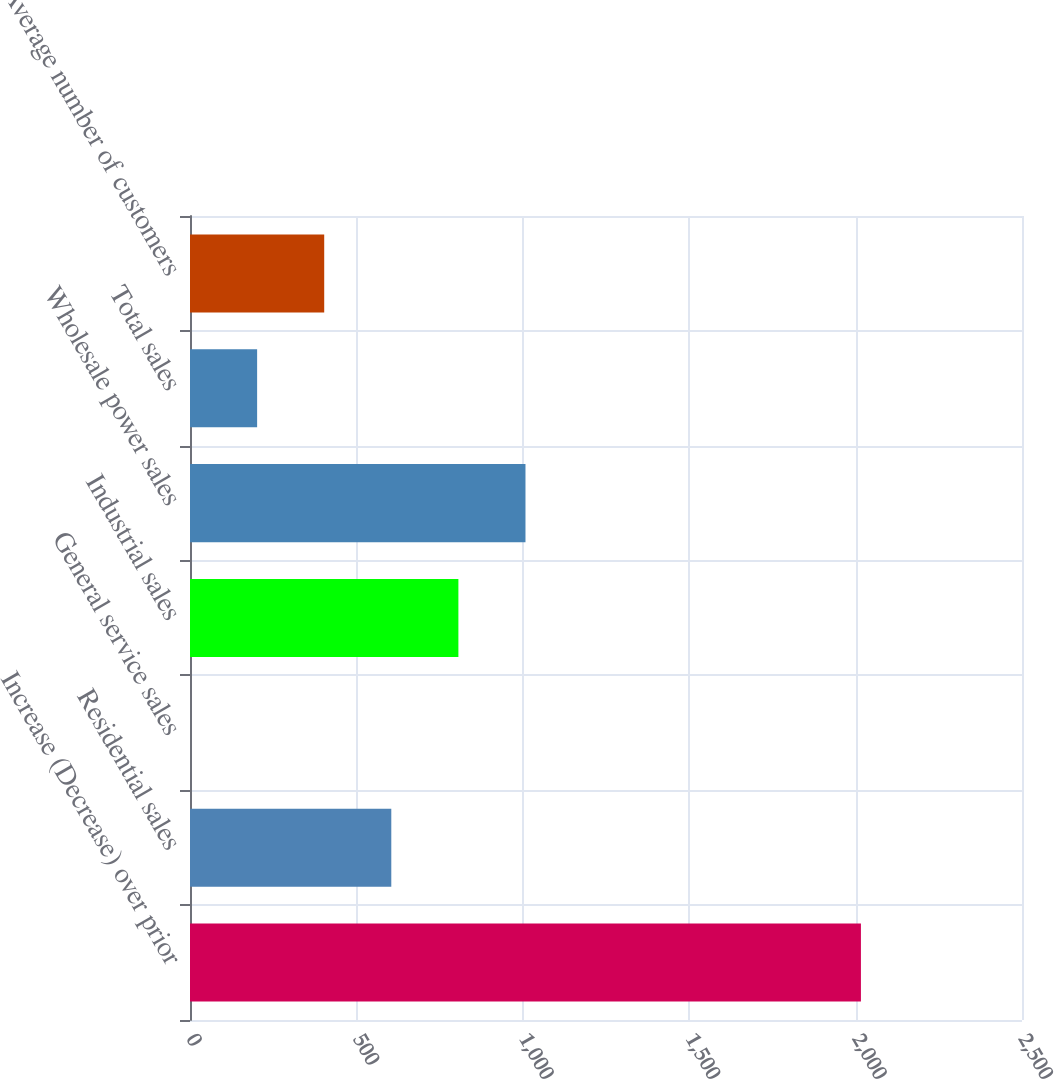Convert chart. <chart><loc_0><loc_0><loc_500><loc_500><bar_chart><fcel>Increase (Decrease) over prior<fcel>Residential sales<fcel>General service sales<fcel>Industrial sales<fcel>Wholesale power sales<fcel>Total sales<fcel>Average number of customers<nl><fcel>2016<fcel>604.87<fcel>0.1<fcel>806.46<fcel>1008.05<fcel>201.69<fcel>403.28<nl></chart> 